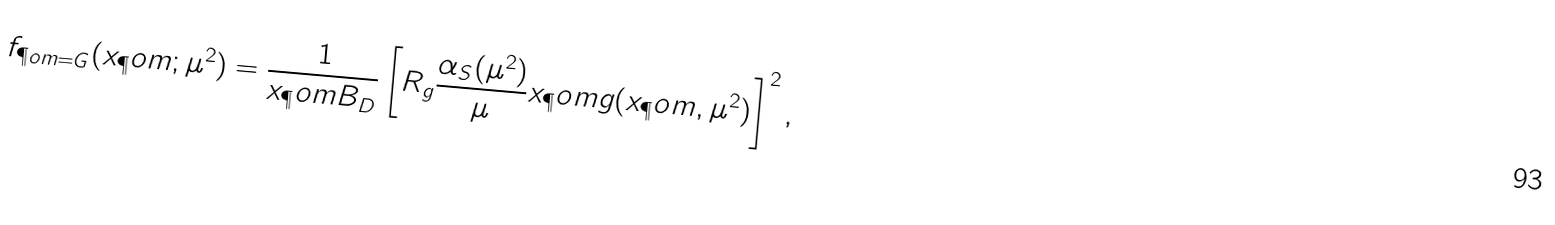<formula> <loc_0><loc_0><loc_500><loc_500>f _ { \P o m = G } ( x _ { \P } o m ; \mu ^ { 2 } ) = \frac { 1 } { x _ { \P } o m B _ { D } } \left [ R _ { g } \frac { \alpha _ { S } ( \mu ^ { 2 } ) } { \mu } x _ { \P } o m g ( x _ { \P } o m , \mu ^ { 2 } ) \right ] ^ { 2 } ,</formula> 